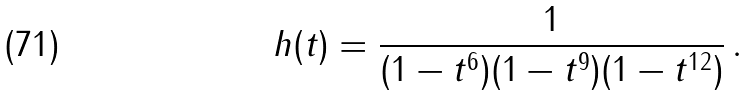Convert formula to latex. <formula><loc_0><loc_0><loc_500><loc_500>h ( t ) = \frac { 1 } { ( 1 - t ^ { 6 } ) ( 1 - t ^ { 9 } ) ( 1 - t ^ { 1 2 } ) } \, .</formula> 